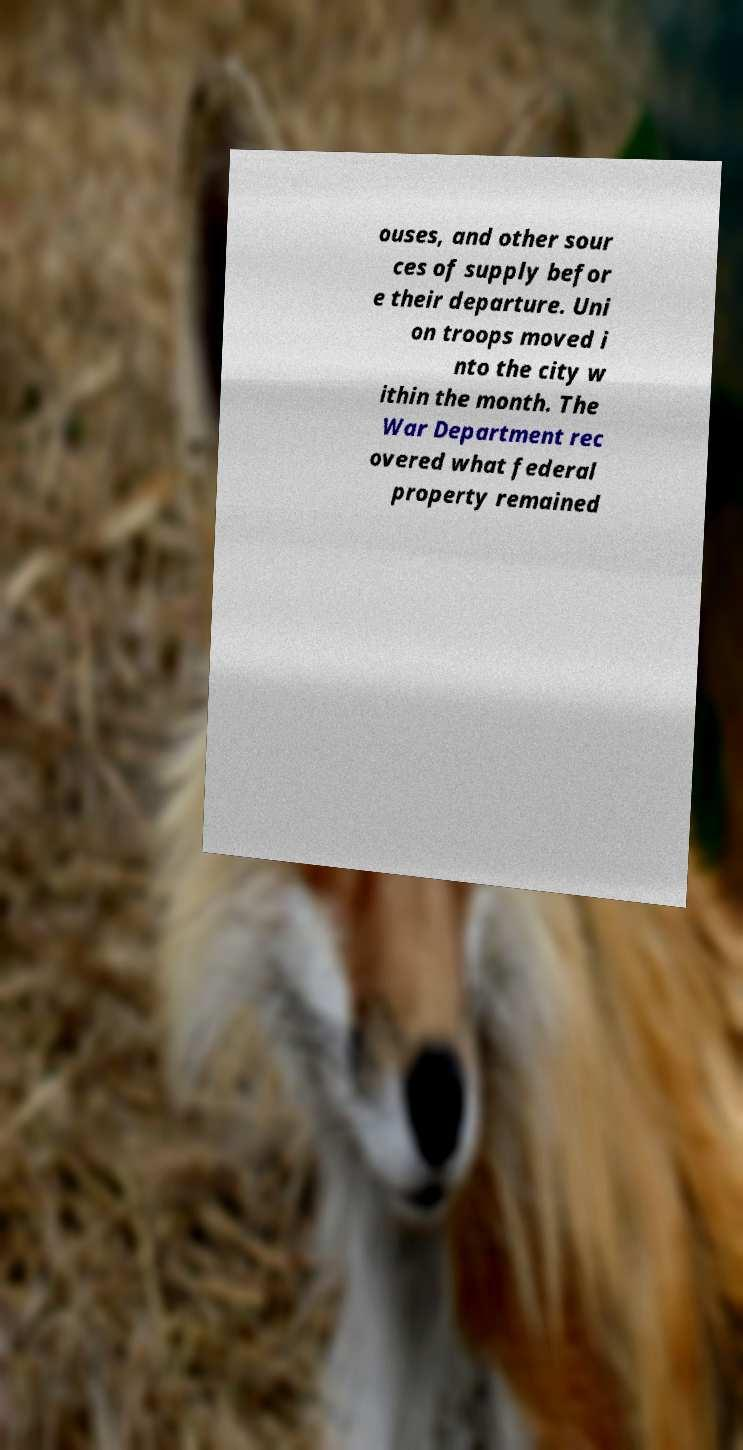Can you accurately transcribe the text from the provided image for me? ouses, and other sour ces of supply befor e their departure. Uni on troops moved i nto the city w ithin the month. The War Department rec overed what federal property remained 